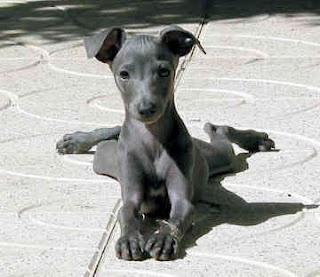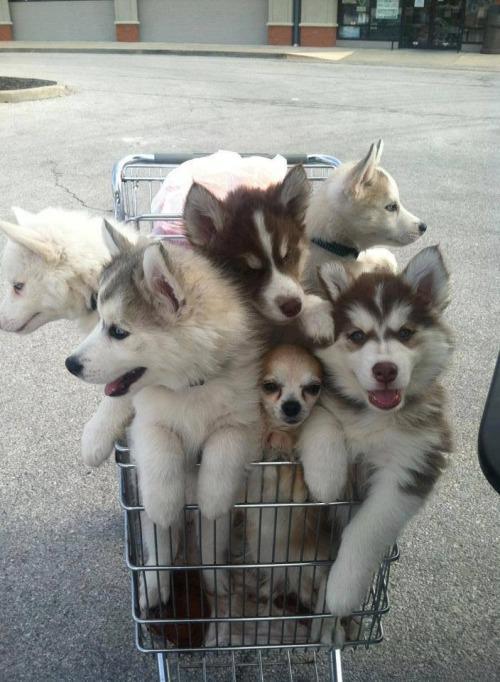The first image is the image on the left, the second image is the image on the right. Given the left and right images, does the statement "An image contains two solid-colored hound dogs." hold true? Answer yes or no. No. The first image is the image on the left, the second image is the image on the right. For the images shown, is this caption "Two dogs pose together in one of the pictures." true? Answer yes or no. No. 